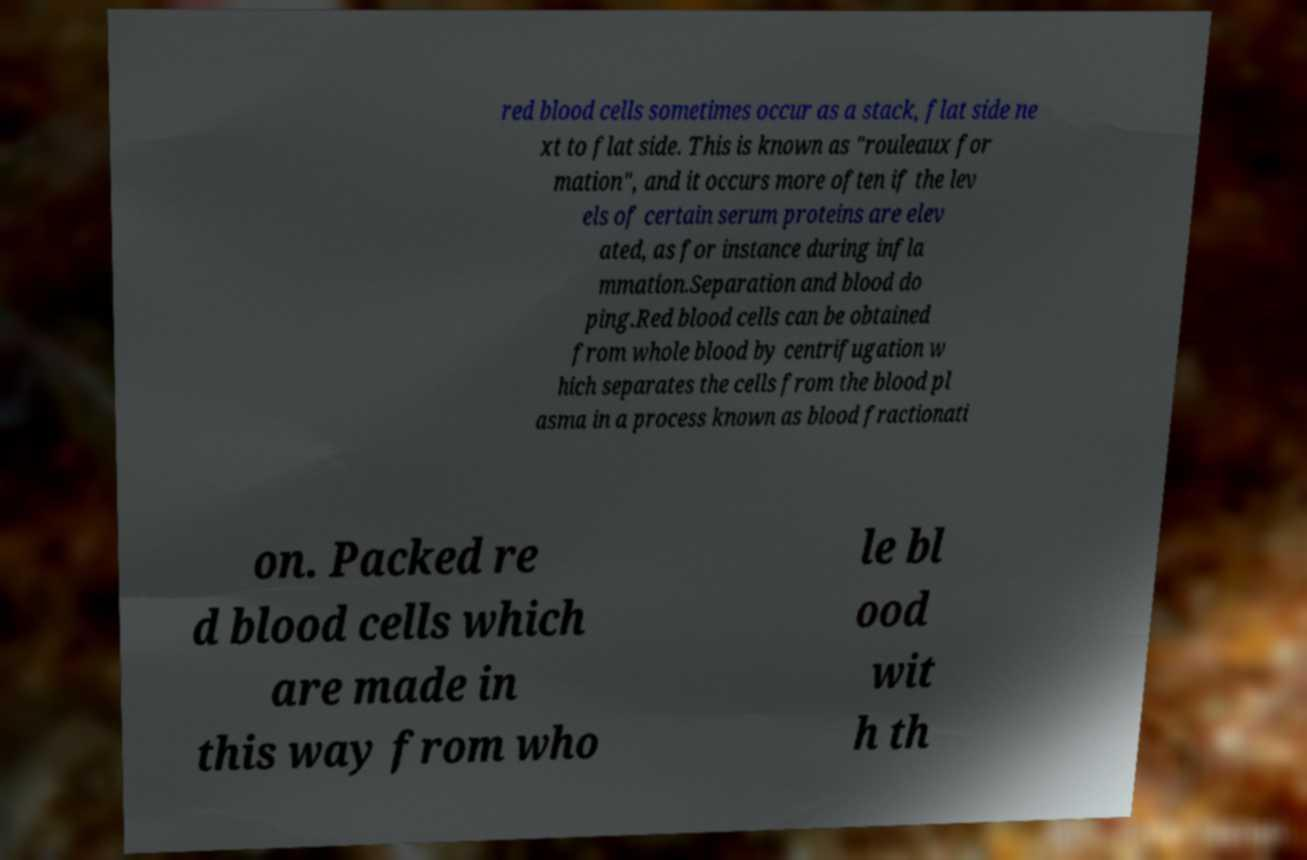Please identify and transcribe the text found in this image. red blood cells sometimes occur as a stack, flat side ne xt to flat side. This is known as "rouleaux for mation", and it occurs more often if the lev els of certain serum proteins are elev ated, as for instance during infla mmation.Separation and blood do ping.Red blood cells can be obtained from whole blood by centrifugation w hich separates the cells from the blood pl asma in a process known as blood fractionati on. Packed re d blood cells which are made in this way from who le bl ood wit h th 